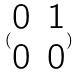Convert formula to latex. <formula><loc_0><loc_0><loc_500><loc_500>( \begin{matrix} 0 & 1 \\ 0 & 0 \end{matrix} )</formula> 